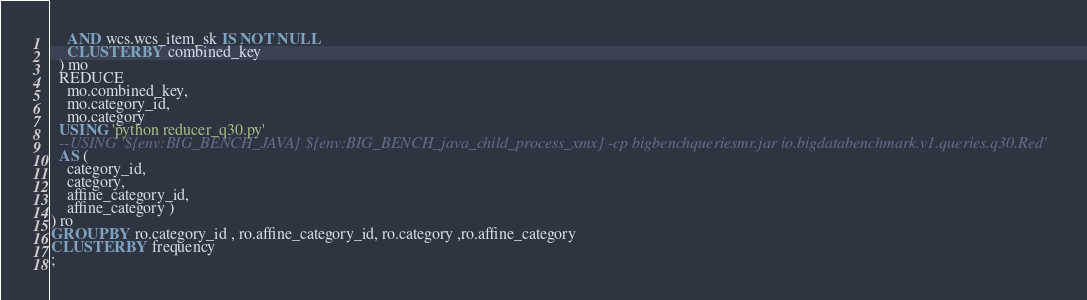<code> <loc_0><loc_0><loc_500><loc_500><_SQL_>    AND wcs.wcs_item_sk IS NOT NULL
    CLUSTER BY combined_key
  ) mo
  REDUCE
    mo.combined_key,
    mo.category_id,
    mo.category
  USING 'python reducer_q30.py'
  --USING '${env:BIG_BENCH_JAVA} ${env:BIG_BENCH_java_child_process_xmx} -cp bigbenchqueriesmr.jar io.bigdatabenchmark.v1.queries.q30.Red'
  AS (
    category_id,
    category,
    affine_category_id,
    affine_category )
) ro
GROUP BY ro.category_id , ro.affine_category_id, ro.category ,ro.affine_category
CLUSTER BY frequency
;
</code> 